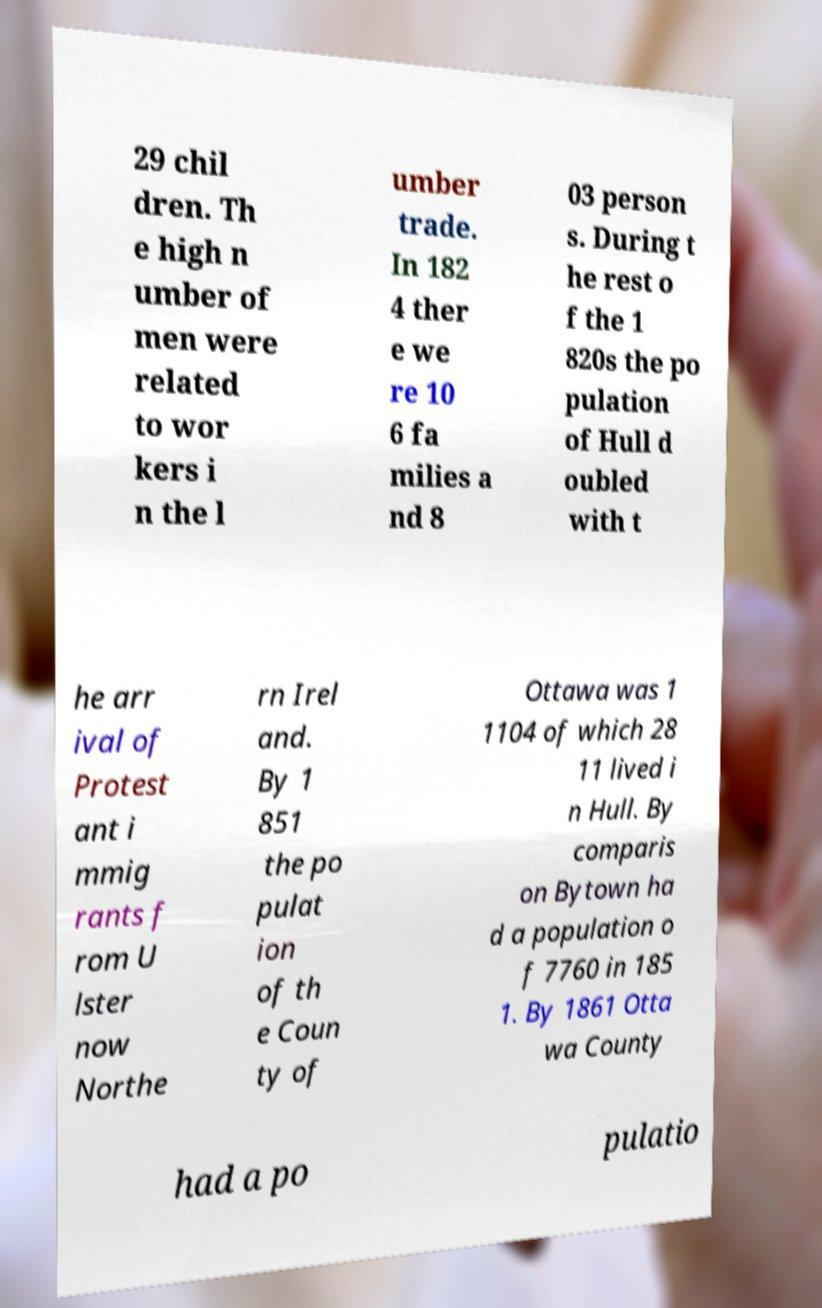Can you read and provide the text displayed in the image?This photo seems to have some interesting text. Can you extract and type it out for me? 29 chil dren. Th e high n umber of men were related to wor kers i n the l umber trade. In 182 4 ther e we re 10 6 fa milies a nd 8 03 person s. During t he rest o f the 1 820s the po pulation of Hull d oubled with t he arr ival of Protest ant i mmig rants f rom U lster now Northe rn Irel and. By 1 851 the po pulat ion of th e Coun ty of Ottawa was 1 1104 of which 28 11 lived i n Hull. By comparis on Bytown ha d a population o f 7760 in 185 1. By 1861 Otta wa County had a po pulatio 